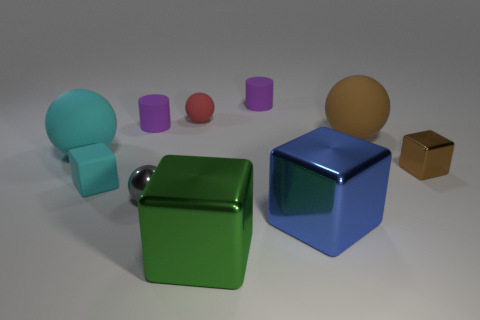How many tiny red cylinders are there?
Make the answer very short. 0. What number of cylinders are large objects or brown matte things?
Give a very brief answer. 0. There is a matte cube that is the same size as the gray shiny sphere; what color is it?
Your answer should be very brief. Cyan. What number of balls are both to the right of the large blue shiny cube and on the left side of the big brown thing?
Your answer should be very brief. 0. What material is the blue block?
Make the answer very short. Metal. What number of things are either small brown metallic cylinders or tiny objects?
Keep it short and to the point. 6. There is a cyan cube to the left of the red ball; is it the same size as the ball that is in front of the big cyan sphere?
Offer a very short reply. Yes. What number of other things are there of the same size as the cyan matte sphere?
Your answer should be compact. 3. How many objects are tiny cubes that are to the right of the gray metallic sphere or big objects behind the tiny cyan rubber block?
Ensure brevity in your answer.  3. Are the gray ball and the cyan object left of the tiny matte cube made of the same material?
Your answer should be compact. No. 